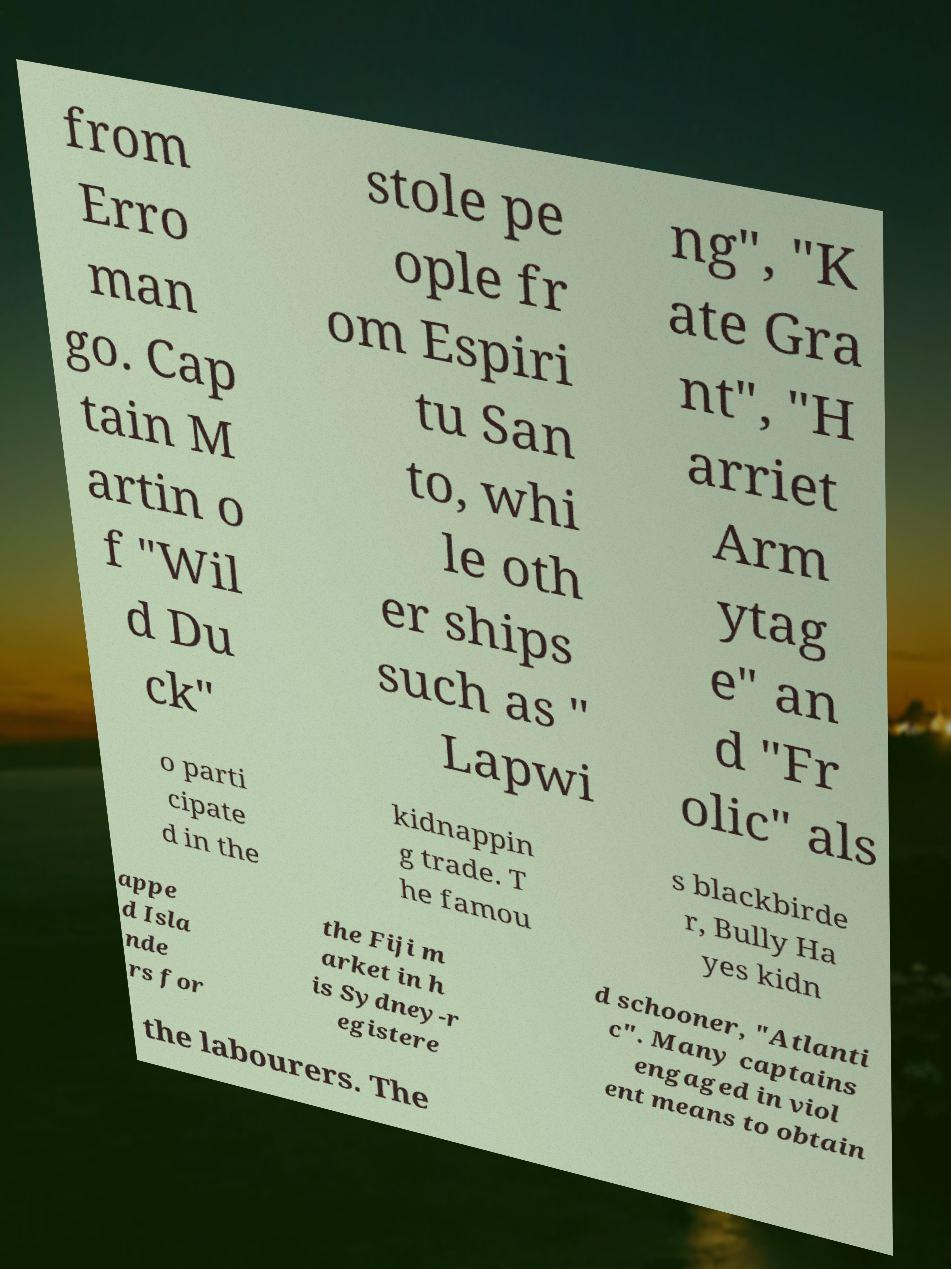Please identify and transcribe the text found in this image. from Erro man go. Cap tain M artin o f "Wil d Du ck" stole pe ople fr om Espiri tu San to, whi le oth er ships such as " Lapwi ng", "K ate Gra nt", "H arriet Arm ytag e" an d "Fr olic" als o parti cipate d in the kidnappin g trade. T he famou s blackbirde r, Bully Ha yes kidn appe d Isla nde rs for the Fiji m arket in h is Sydney-r egistere d schooner, "Atlanti c". Many captains engaged in viol ent means to obtain the labourers. The 